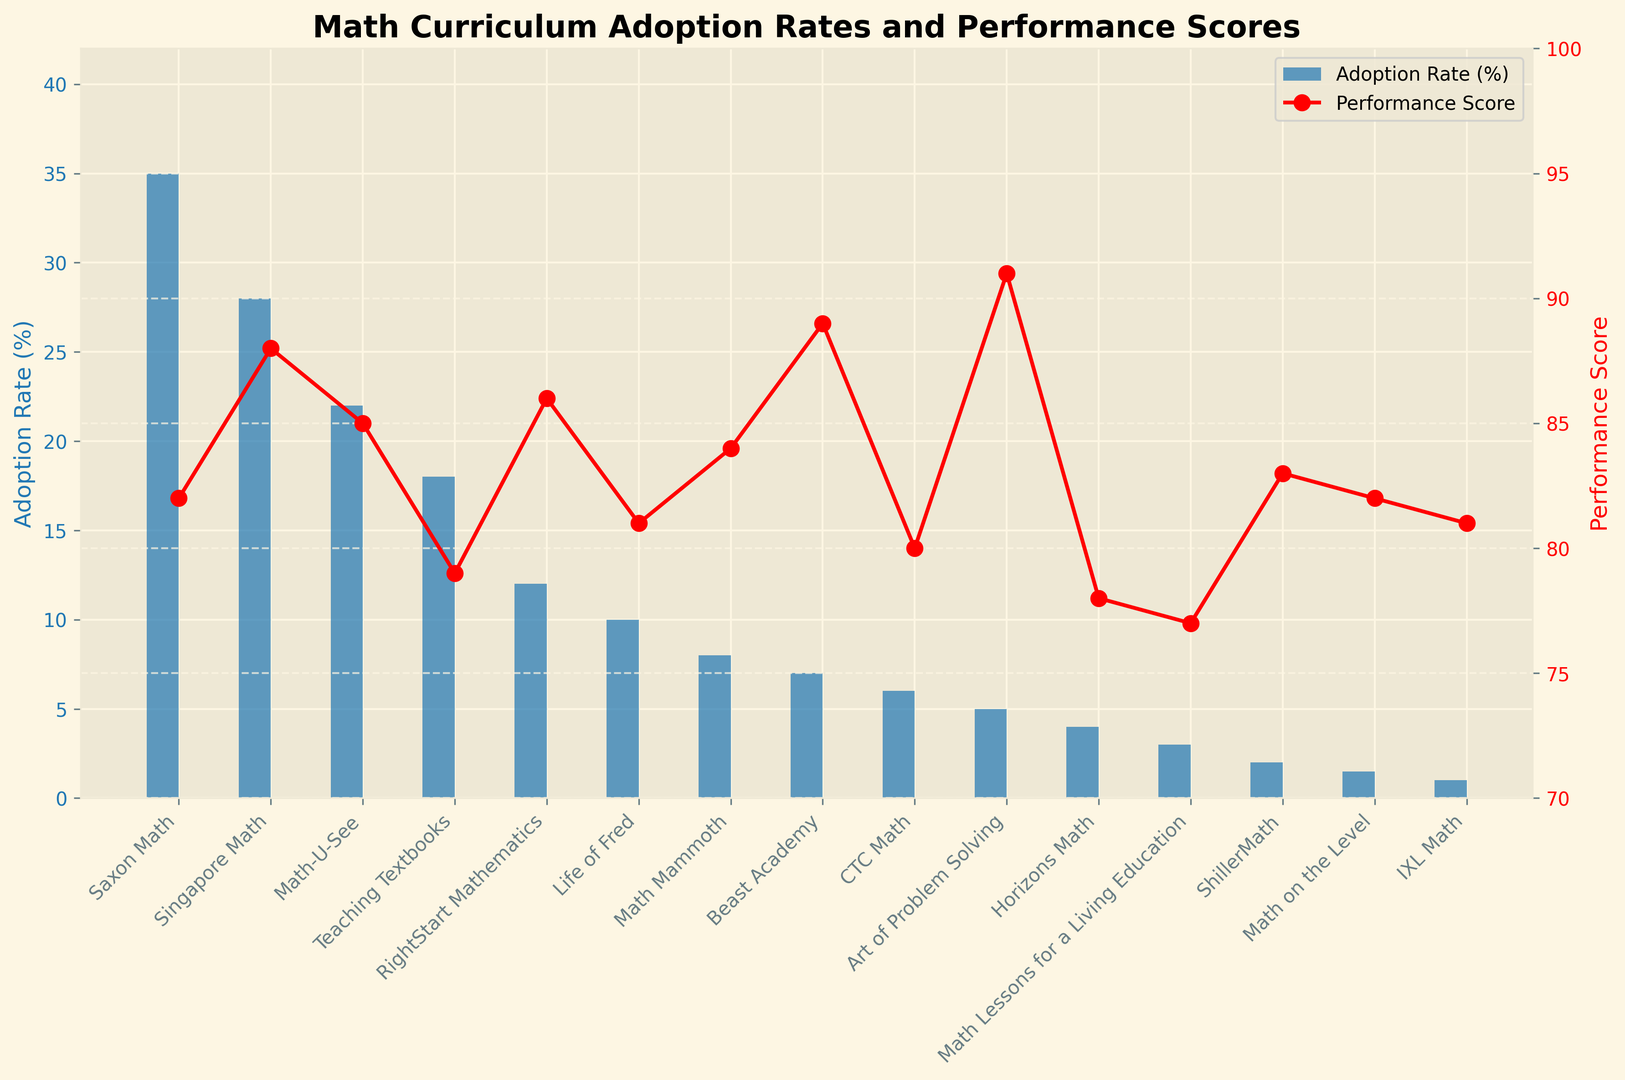What's the difference between the performance scores of Singapore Math and Teaching Textbooks? First, locate the performance scores of Singapore Math and Teaching Textbooks on the chart, which are 88 and 79 respectively. Then, subtract the score of Teaching Textbooks from that of Singapore Math: 88 - 79 = 9.
Answer: 9 Which curriculum has the highest adoption rate? Identify the tallest blue bar on the chart, which corresponds to Saxon Math. The adoption rate for Saxon Math is 35%.
Answer: Saxon Math What is the average performance score of Math-U-See, RightStart Mathematics, and Life of Fred? First, find the performance scores of Math-U-See (85), RightStart Mathematics (86), and Life of Fred (81). Sum these scores: 85 + 86 + 81 = 252. Then, divide by the number of curricula: 252 / 3 = 84.
Answer: 84 Compare the adoption rate of CTC Math to Math Mammoth. Which is higher and by how much? Note the adoption rates: CTC Math (6%) and Math Mammoth (8%). Subtract the smaller from the larger: 8% - 6% = 2%.
Answer: Math Mammoth by 2% Which curriculum has the highest performance score, and what is it? Locate the highest point on the red line, which corresponds to Art of Problem Solving with a performance score of 91.
Answer: Art of Problem Solving, 91 Is there a curriculum with an adoption rate below 10% but a performance score above 85? Check the curricula with adoption rates below 10%: Life of Fred (81), Math Mammoth (84), Beast Academy (89), CTC Math (80), AoPS (91), Horizons Math (78), Math Lessons for a Living Education (77), ShillerMath (83), Math on the Level (82), IXL Math (81). Among these, Beast Academy has a score of 89 and AoPS has a score of 91.
Answer: Beast Academy and Art of Problem Solving What is the range of adoption rates? Identify the highest adoption rate (Saxon Math: 35%) and the lowest adoption rate (IXL Math: 1%). Subtract the lowest from the highest: 35% - 1% = 34%.
Answer: 34% Does any curriculum have both an adoption rate and performance score above 50%? Review the adoption and performance scores: None exceed 50% for both metrics simultaneously.
Answer: No Are there more curricula with adoption rates above 20% or performance scores above 80? Count the curricula with adoption rates above 20%: Saxon Math (35%), Singapore Math (28%), Math-U-See (22%). This totals to 3. Next, count those with performance scores above 80: Saxon Math (82), Singapore Math (88), Math-U-See (85), RightStart Mathematics (86), Life of Fred (81), Math Mammoth (84), Beast Academy (89), Art of Problem Solving (91), ShillerMath (83), Math on the Level (82), IXL Math (81). This totals to 11.
Answer: More with performance scores above 80 